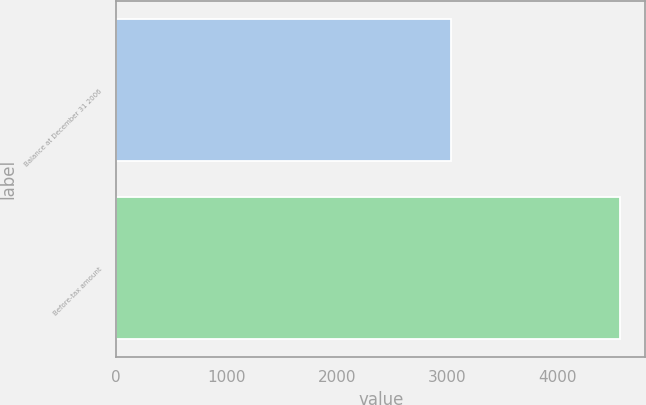<chart> <loc_0><loc_0><loc_500><loc_500><bar_chart><fcel>Balance at December 31 2006<fcel>Before-tax amount<nl><fcel>3038<fcel>4571<nl></chart> 